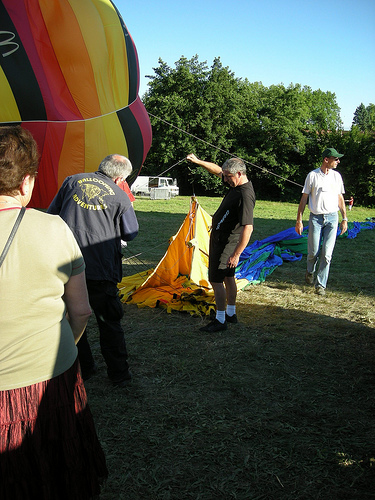<image>
Is there a man behind the woman? Yes. From this viewpoint, the man is positioned behind the woman, with the woman partially or fully occluding the man. 